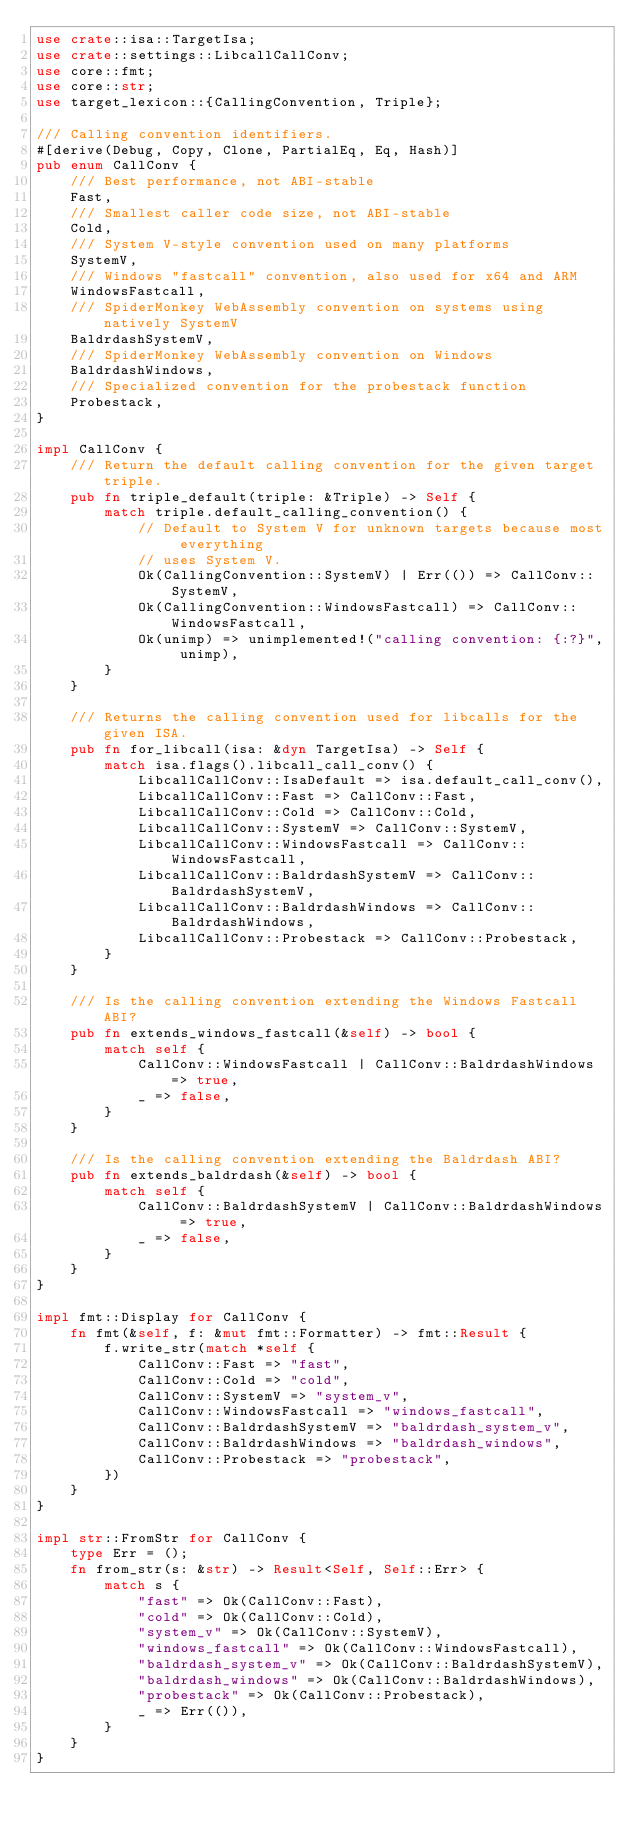Convert code to text. <code><loc_0><loc_0><loc_500><loc_500><_Rust_>use crate::isa::TargetIsa;
use crate::settings::LibcallCallConv;
use core::fmt;
use core::str;
use target_lexicon::{CallingConvention, Triple};

/// Calling convention identifiers.
#[derive(Debug, Copy, Clone, PartialEq, Eq, Hash)]
pub enum CallConv {
    /// Best performance, not ABI-stable
    Fast,
    /// Smallest caller code size, not ABI-stable
    Cold,
    /// System V-style convention used on many platforms
    SystemV,
    /// Windows "fastcall" convention, also used for x64 and ARM
    WindowsFastcall,
    /// SpiderMonkey WebAssembly convention on systems using natively SystemV
    BaldrdashSystemV,
    /// SpiderMonkey WebAssembly convention on Windows
    BaldrdashWindows,
    /// Specialized convention for the probestack function
    Probestack,
}

impl CallConv {
    /// Return the default calling convention for the given target triple.
    pub fn triple_default(triple: &Triple) -> Self {
        match triple.default_calling_convention() {
            // Default to System V for unknown targets because most everything
            // uses System V.
            Ok(CallingConvention::SystemV) | Err(()) => CallConv::SystemV,
            Ok(CallingConvention::WindowsFastcall) => CallConv::WindowsFastcall,
            Ok(unimp) => unimplemented!("calling convention: {:?}", unimp),
        }
    }

    /// Returns the calling convention used for libcalls for the given ISA.
    pub fn for_libcall(isa: &dyn TargetIsa) -> Self {
        match isa.flags().libcall_call_conv() {
            LibcallCallConv::IsaDefault => isa.default_call_conv(),
            LibcallCallConv::Fast => CallConv::Fast,
            LibcallCallConv::Cold => CallConv::Cold,
            LibcallCallConv::SystemV => CallConv::SystemV,
            LibcallCallConv::WindowsFastcall => CallConv::WindowsFastcall,
            LibcallCallConv::BaldrdashSystemV => CallConv::BaldrdashSystemV,
            LibcallCallConv::BaldrdashWindows => CallConv::BaldrdashWindows,
            LibcallCallConv::Probestack => CallConv::Probestack,
        }
    }

    /// Is the calling convention extending the Windows Fastcall ABI?
    pub fn extends_windows_fastcall(&self) -> bool {
        match self {
            CallConv::WindowsFastcall | CallConv::BaldrdashWindows => true,
            _ => false,
        }
    }

    /// Is the calling convention extending the Baldrdash ABI?
    pub fn extends_baldrdash(&self) -> bool {
        match self {
            CallConv::BaldrdashSystemV | CallConv::BaldrdashWindows => true,
            _ => false,
        }
    }
}

impl fmt::Display for CallConv {
    fn fmt(&self, f: &mut fmt::Formatter) -> fmt::Result {
        f.write_str(match *self {
            CallConv::Fast => "fast",
            CallConv::Cold => "cold",
            CallConv::SystemV => "system_v",
            CallConv::WindowsFastcall => "windows_fastcall",
            CallConv::BaldrdashSystemV => "baldrdash_system_v",
            CallConv::BaldrdashWindows => "baldrdash_windows",
            CallConv::Probestack => "probestack",
        })
    }
}

impl str::FromStr for CallConv {
    type Err = ();
    fn from_str(s: &str) -> Result<Self, Self::Err> {
        match s {
            "fast" => Ok(CallConv::Fast),
            "cold" => Ok(CallConv::Cold),
            "system_v" => Ok(CallConv::SystemV),
            "windows_fastcall" => Ok(CallConv::WindowsFastcall),
            "baldrdash_system_v" => Ok(CallConv::BaldrdashSystemV),
            "baldrdash_windows" => Ok(CallConv::BaldrdashWindows),
            "probestack" => Ok(CallConv::Probestack),
            _ => Err(()),
        }
    }
}
</code> 